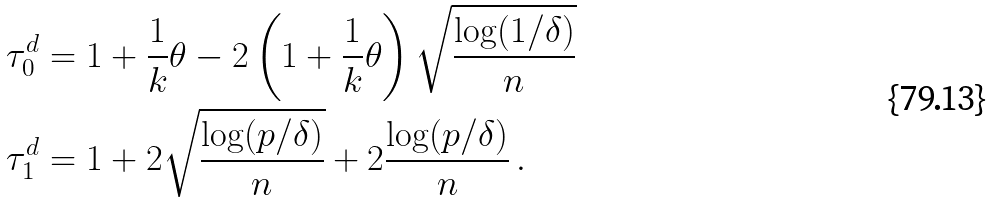Convert formula to latex. <formula><loc_0><loc_0><loc_500><loc_500>\tau ^ { d } _ { 0 } & = 1 + \frac { 1 } { k } \theta - 2 \left ( 1 + \frac { 1 } { k } \theta \right ) \sqrt { \frac { \log ( 1 / \delta ) } { n } } \\ \tau ^ { d } _ { 1 } & = 1 + 2 \sqrt { \frac { \log ( p / \delta ) } { n } } + 2 \frac { \log ( p / \delta ) } { n } \, .</formula> 